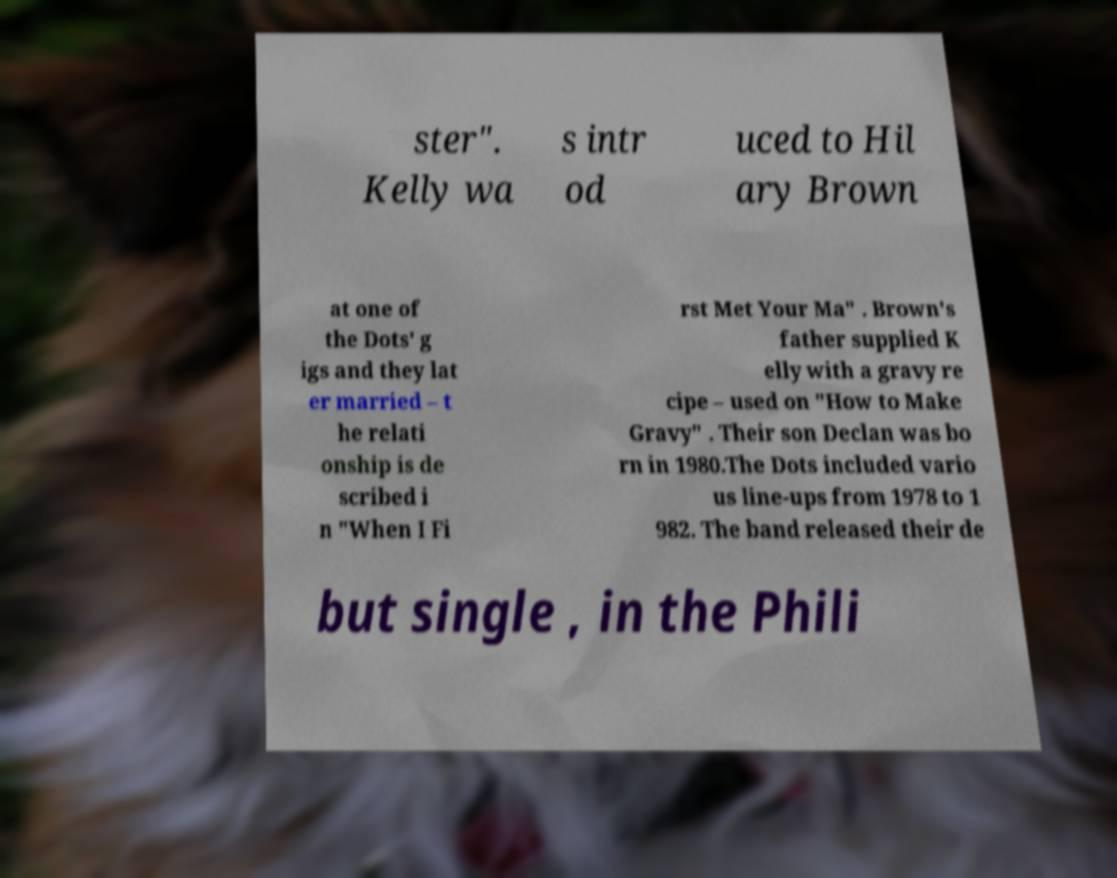Please read and relay the text visible in this image. What does it say? ster". Kelly wa s intr od uced to Hil ary Brown at one of the Dots' g igs and they lat er married – t he relati onship is de scribed i n "When I Fi rst Met Your Ma" . Brown's father supplied K elly with a gravy re cipe – used on "How to Make Gravy" . Their son Declan was bo rn in 1980.The Dots included vario us line-ups from 1978 to 1 982. The band released their de but single , in the Phili 